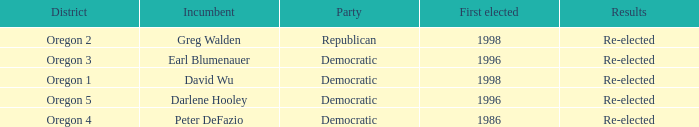Which district has a Democratic incumbent that was first elected before 1996? Oregon 4. 